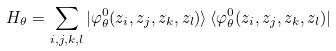Convert formula to latex. <formula><loc_0><loc_0><loc_500><loc_500>H _ { \theta } = \sum _ { i , j , k , l } | \varphi ^ { 0 } _ { \theta } ( z _ { i } , z _ { j } , z _ { k } , z _ { l } ) \rangle \, \langle \varphi ^ { 0 } _ { \theta } ( z _ { i } , z _ { j } , z _ { k } , z _ { l } ) |</formula> 